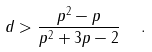<formula> <loc_0><loc_0><loc_500><loc_500>d > \frac { p ^ { 2 } - p } { p ^ { 2 } + 3 p - 2 } \ \ .</formula> 